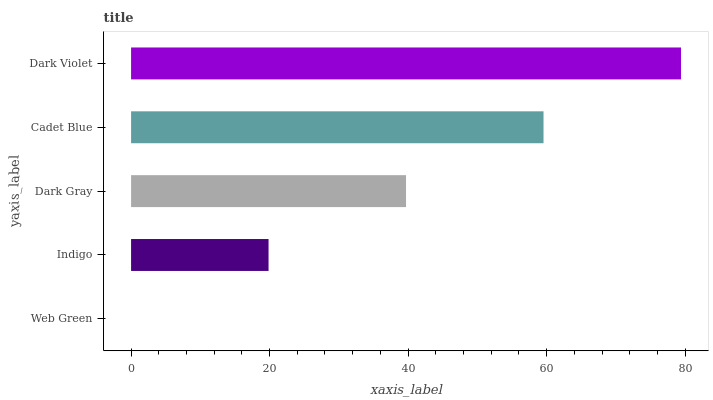Is Web Green the minimum?
Answer yes or no. Yes. Is Dark Violet the maximum?
Answer yes or no. Yes. Is Indigo the minimum?
Answer yes or no. No. Is Indigo the maximum?
Answer yes or no. No. Is Indigo greater than Web Green?
Answer yes or no. Yes. Is Web Green less than Indigo?
Answer yes or no. Yes. Is Web Green greater than Indigo?
Answer yes or no. No. Is Indigo less than Web Green?
Answer yes or no. No. Is Dark Gray the high median?
Answer yes or no. Yes. Is Dark Gray the low median?
Answer yes or no. Yes. Is Cadet Blue the high median?
Answer yes or no. No. Is Cadet Blue the low median?
Answer yes or no. No. 